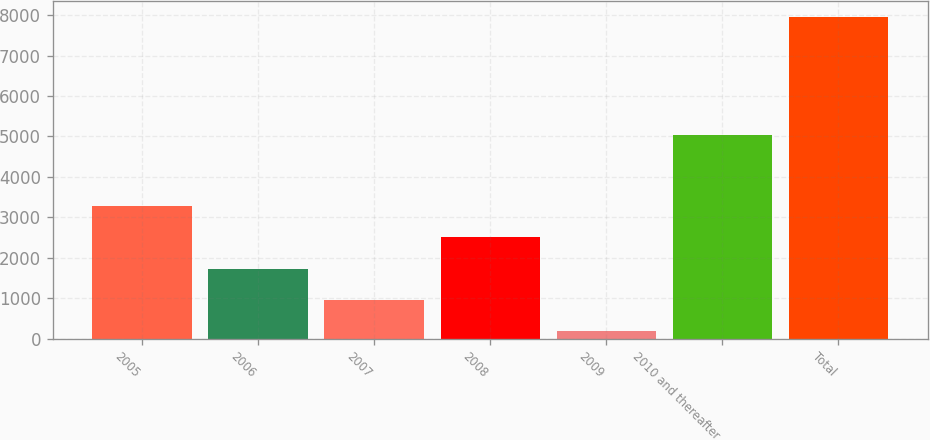Convert chart to OTSL. <chart><loc_0><loc_0><loc_500><loc_500><bar_chart><fcel>2005<fcel>2006<fcel>2007<fcel>2008<fcel>2009<fcel>2010 and thereafter<fcel>Total<nl><fcel>3288.6<fcel>1732.8<fcel>954.9<fcel>2510.7<fcel>177<fcel>5025<fcel>7956<nl></chart> 